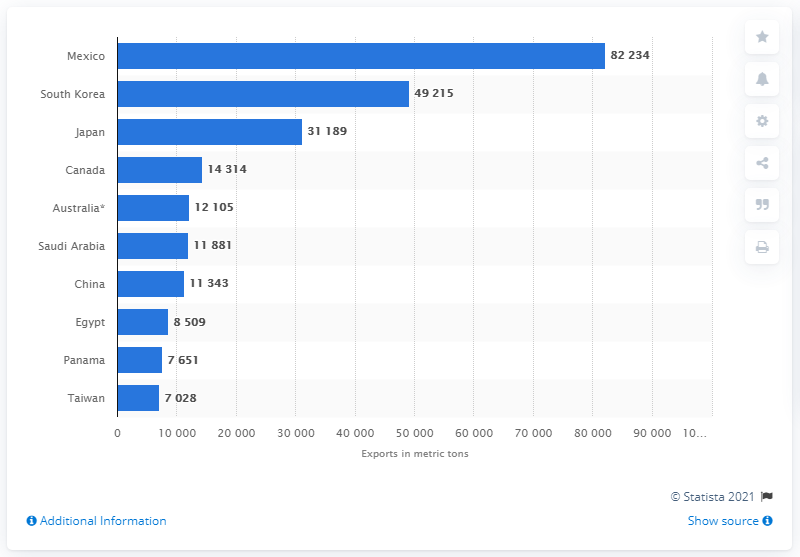List a handful of essential elements in this visual. In 2013, a total of 49,215 metric tons of cheese and curd were exported to South Korea. 